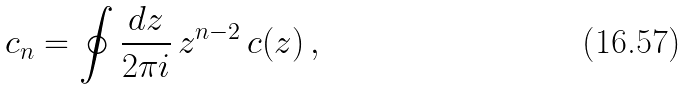Convert formula to latex. <formula><loc_0><loc_0><loc_500><loc_500>c _ { n } = \oint \frac { d z } { 2 \pi i } \, z ^ { n - 2 } \, c ( z ) \, ,</formula> 